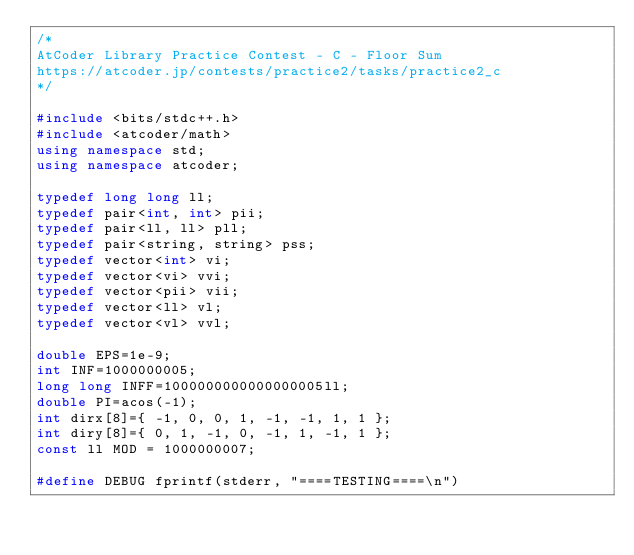Convert code to text. <code><loc_0><loc_0><loc_500><loc_500><_C++_>/*
AtCoder Library Practice Contest - C - Floor Sum
https://atcoder.jp/contests/practice2/tasks/practice2_c
*/

#include <bits/stdc++.h>
#include <atcoder/math>
using namespace std;
using namespace atcoder;

typedef long long ll;
typedef pair<int, int> pii;
typedef pair<ll, ll> pll;
typedef pair<string, string> pss;
typedef vector<int> vi;
typedef vector<vi> vvi;
typedef vector<pii> vii;
typedef vector<ll> vl;
typedef vector<vl> vvl;

double EPS=1e-9;
int INF=1000000005;
long long INFF=1000000000000000005ll;
double PI=acos(-1);
int dirx[8]={ -1, 0, 0, 1, -1, -1, 1, 1 };
int diry[8]={ 0, 1, -1, 0, -1, 1, -1, 1 };
const ll MOD = 1000000007;

#define DEBUG fprintf(stderr, "====TESTING====\n")</code> 